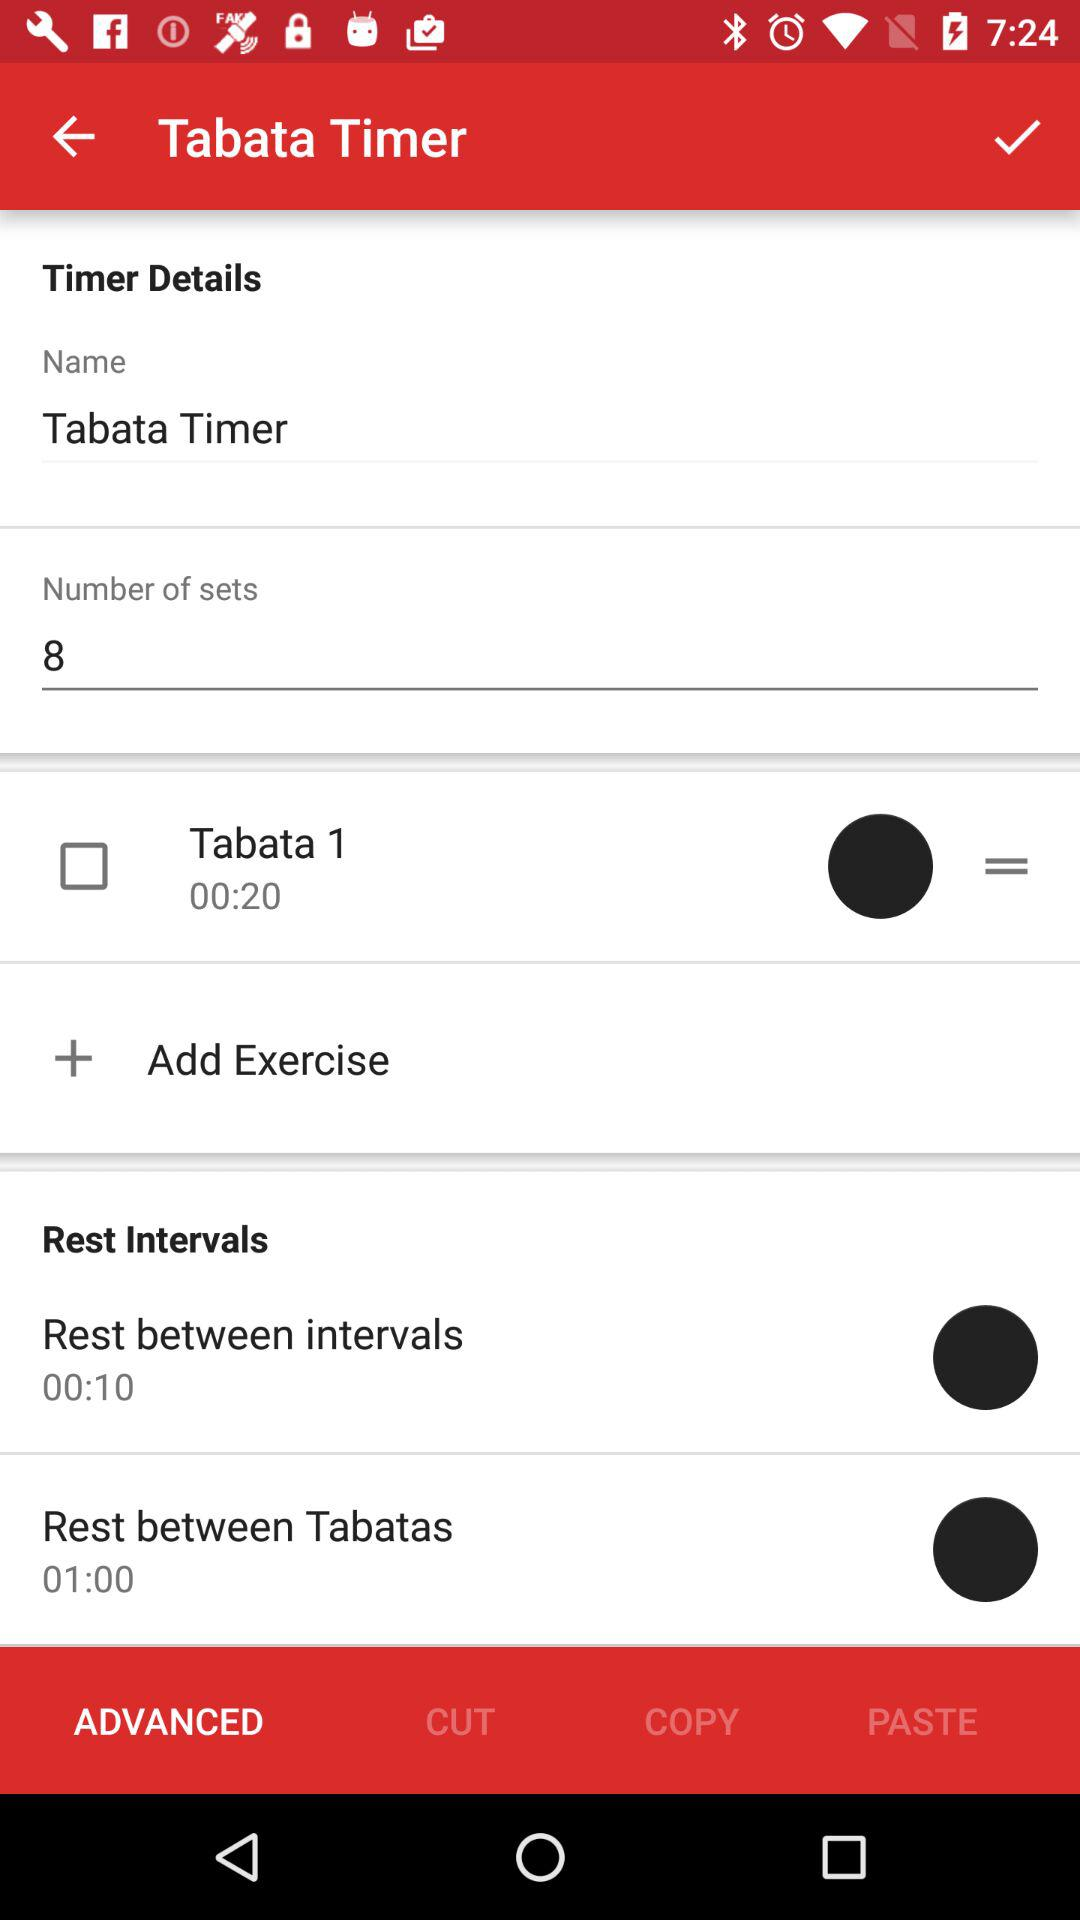What is the duration of the rest between intervals? The duration is 00:10. 